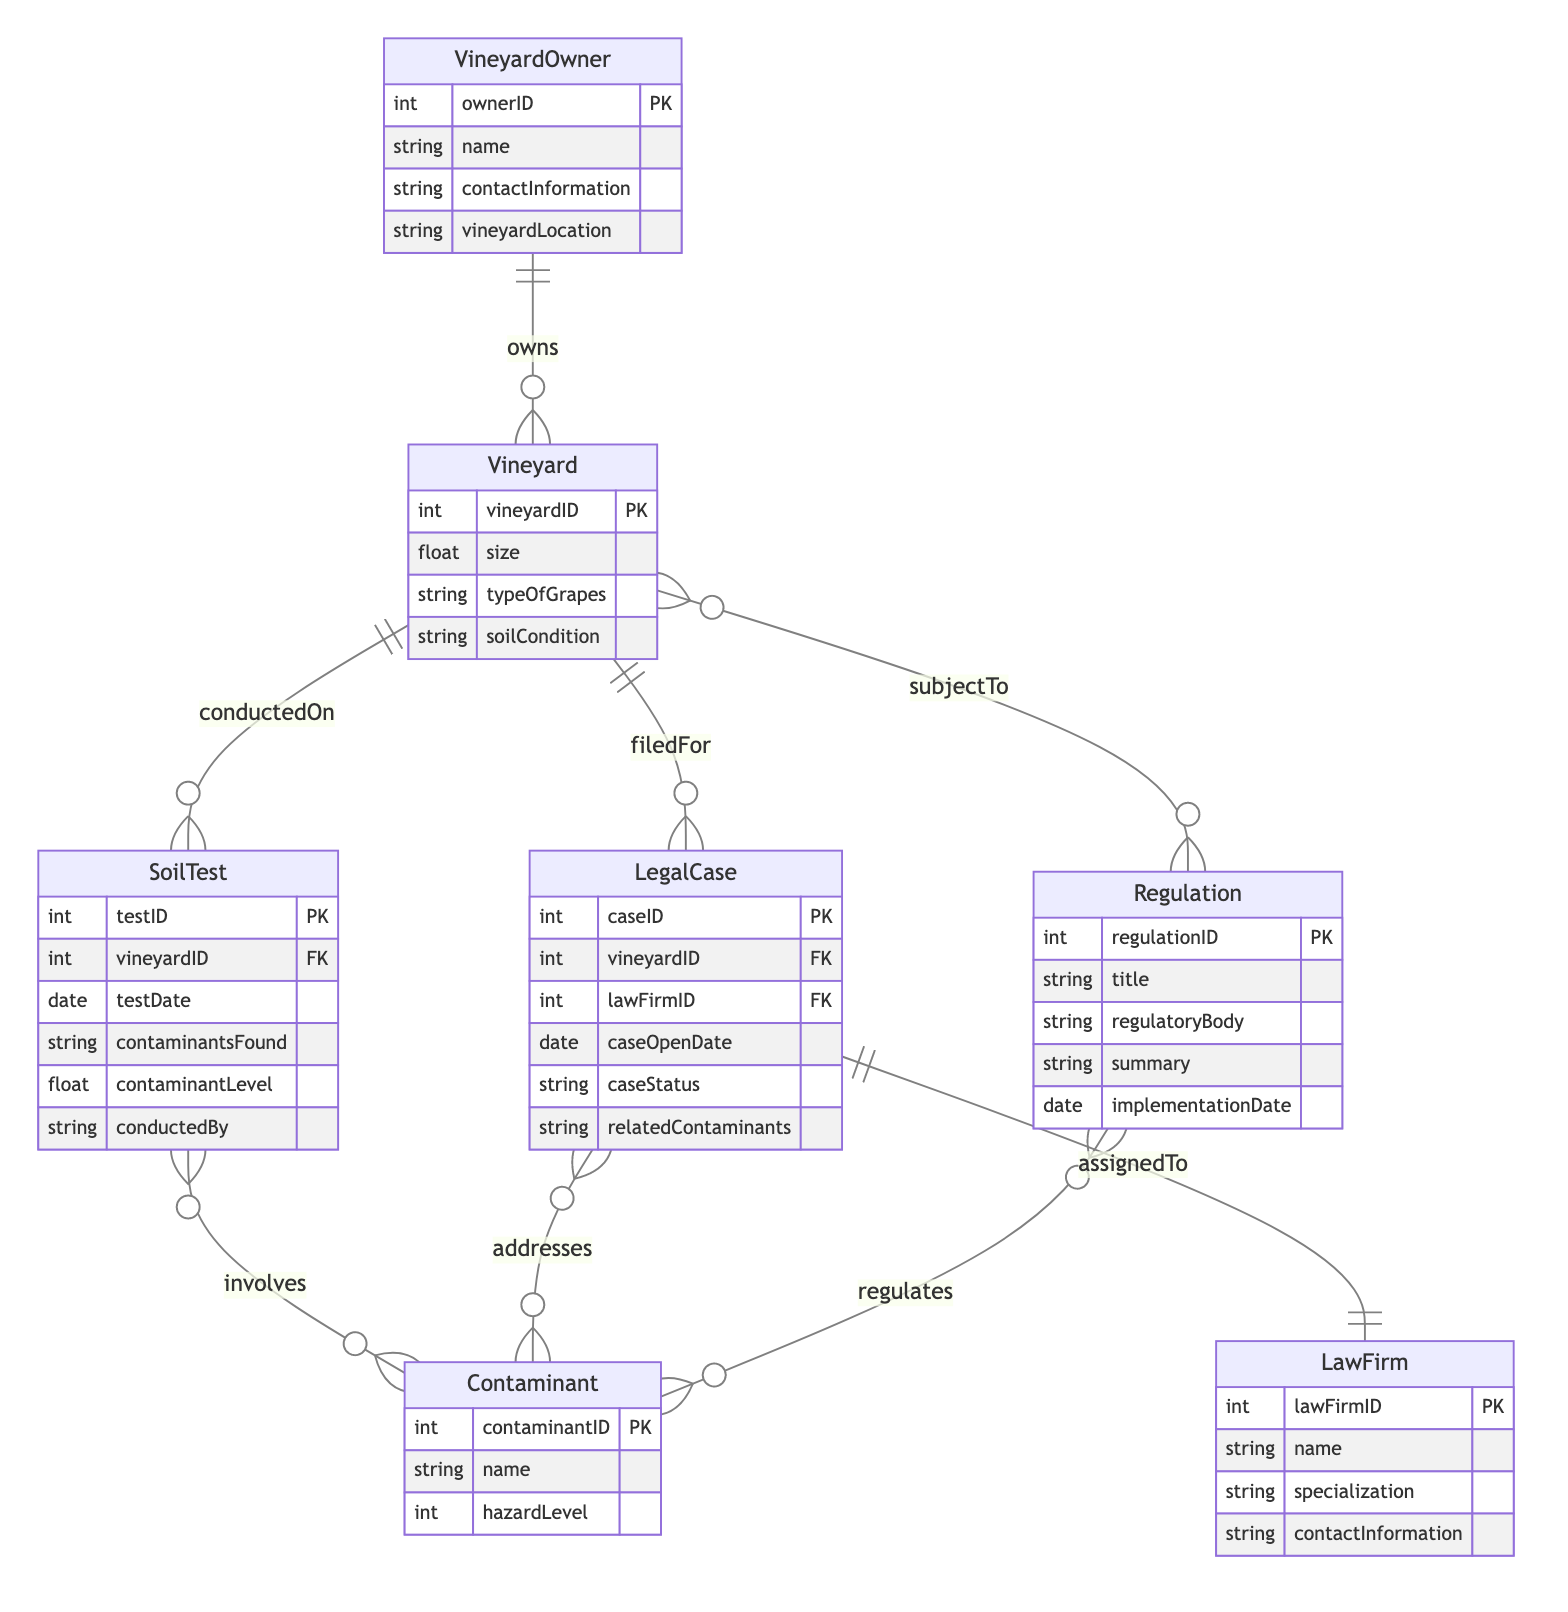What are the main entities in this diagram? The main entities are VineyardOwner, Vineyard, SoilTest, Contaminant, LawFirm, LegalCase, and Regulation. These entities represent different aspects related to soil contamination and legal actions.
Answer: VineyardOwner, Vineyard, SoilTest, Contaminant, LawFirm, LegalCase, Regulation How many relationships are there in the diagram? There are seven relationships outlined in the relationships section of the diagram, each connecting different entities.
Answer: 7 What relationship connects LegalCase and LawFirm? The relationship between LegalCase and LawFirm is labeled "assignedTo," indicating that each legal case is linked with a specific law firm responsible for it.
Answer: assignedTo What is the purpose of the Contaminant entity? The Contaminant entity serves to identify and describe the harmful substances found in soil tests and their associated hazard levels.
Answer: Identify harmful substances Which entity contains the attribute "vineyardLocation"? The attribute "vineyardLocation" is a part of the VineyardOwner entity, which refers to the physical location of the vineyard owned by the vineyard owner.
Answer: VineyardOwner Which entities are directly related to the Vineyard entity? The entities directly related to Vineyard are SoilTest, LegalCase, and Regulation. SoilTest is conducted on the vineyard, LegalCase is filed for the vineyard, and Regulation subjects the vineyard to certain laws.
Answer: SoilTest, LegalCase, Regulation What are the key attributes of the LegalCase entity? The key attributes of the LegalCase entity include caseID, vineyardID, lawFirmID, caseOpenDate, caseStatus, and relatedContaminants, which outline essential details about legal cases.
Answer: caseID, vineyardID, lawFirmID, caseOpenDate, caseStatus, relatedContaminants What does the "involves" relationship indicate? The "involves" relationship indicates which contaminants are found during soil tests, connecting the SoilTest and Contaminant entities in a meaningful way.
Answer: Contaminants found in tests How is the HazardLevel attribute related to the Contaminant entity? The HazardLevel attribute in the Contaminant entity specifies the danger that each contaminant poses, and it connects through the regulations that govern them.
Answer: Indicates danger level What does the "regulates" relationship denote? The "regulates" relationship denotes how specific regulations are associated with certain contaminants, linking the Regulation and Contaminant entities in terms of compliance and control measures.
Answer: Links regulations to contaminants 